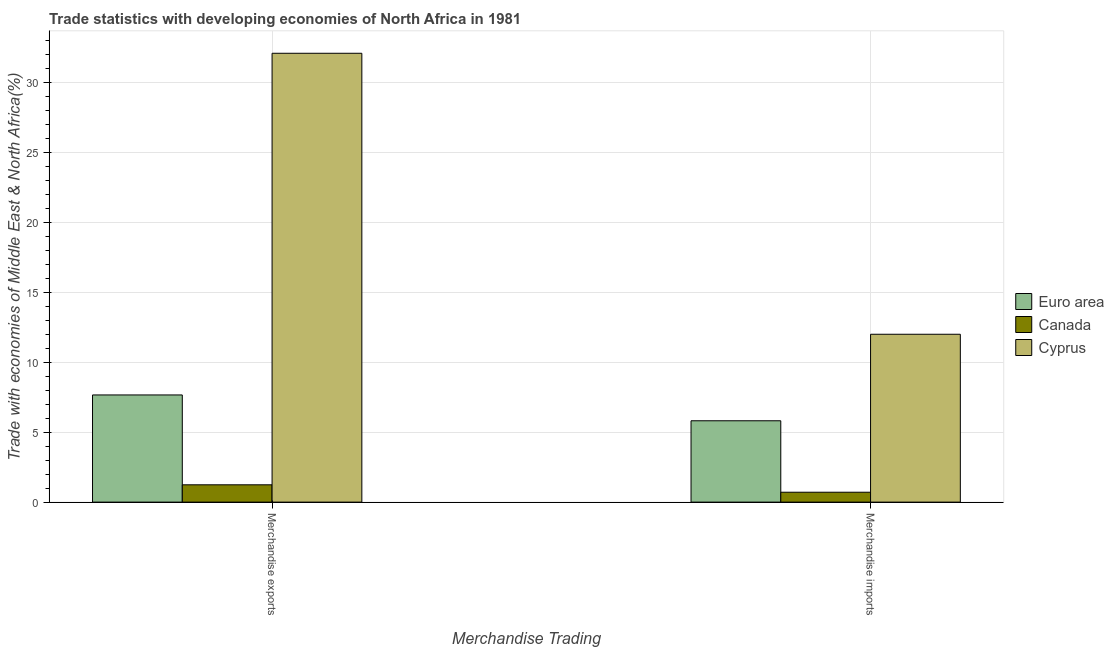How many different coloured bars are there?
Ensure brevity in your answer.  3. Are the number of bars per tick equal to the number of legend labels?
Make the answer very short. Yes. Are the number of bars on each tick of the X-axis equal?
Your answer should be compact. Yes. What is the label of the 1st group of bars from the left?
Provide a short and direct response. Merchandise exports. What is the merchandise exports in Cyprus?
Offer a terse response. 32.08. Across all countries, what is the maximum merchandise imports?
Give a very brief answer. 12. Across all countries, what is the minimum merchandise exports?
Your response must be concise. 1.24. In which country was the merchandise exports maximum?
Give a very brief answer. Cyprus. In which country was the merchandise exports minimum?
Offer a very short reply. Canada. What is the total merchandise imports in the graph?
Your answer should be very brief. 18.52. What is the difference between the merchandise exports in Euro area and that in Canada?
Your answer should be very brief. 6.42. What is the difference between the merchandise exports in Cyprus and the merchandise imports in Canada?
Your response must be concise. 31.37. What is the average merchandise exports per country?
Make the answer very short. 13.66. What is the difference between the merchandise imports and merchandise exports in Euro area?
Ensure brevity in your answer.  -1.85. In how many countries, is the merchandise exports greater than 7 %?
Make the answer very short. 2. What is the ratio of the merchandise exports in Euro area to that in Cyprus?
Your response must be concise. 0.24. Is the merchandise exports in Euro area less than that in Cyprus?
Your answer should be compact. Yes. What does the 3rd bar from the left in Merchandise imports represents?
Offer a very short reply. Cyprus. What does the 1st bar from the right in Merchandise exports represents?
Offer a very short reply. Cyprus. What is the difference between two consecutive major ticks on the Y-axis?
Your answer should be compact. 5. Does the graph contain any zero values?
Provide a short and direct response. No. Does the graph contain grids?
Make the answer very short. Yes. What is the title of the graph?
Your answer should be very brief. Trade statistics with developing economies of North Africa in 1981. Does "Tanzania" appear as one of the legend labels in the graph?
Your answer should be compact. No. What is the label or title of the X-axis?
Give a very brief answer. Merchandise Trading. What is the label or title of the Y-axis?
Provide a succinct answer. Trade with economies of Middle East & North Africa(%). What is the Trade with economies of Middle East & North Africa(%) in Euro area in Merchandise exports?
Provide a succinct answer. 7.66. What is the Trade with economies of Middle East & North Africa(%) of Canada in Merchandise exports?
Ensure brevity in your answer.  1.24. What is the Trade with economies of Middle East & North Africa(%) in Cyprus in Merchandise exports?
Provide a short and direct response. 32.08. What is the Trade with economies of Middle East & North Africa(%) in Euro area in Merchandise imports?
Give a very brief answer. 5.81. What is the Trade with economies of Middle East & North Africa(%) in Canada in Merchandise imports?
Offer a terse response. 0.71. What is the Trade with economies of Middle East & North Africa(%) in Cyprus in Merchandise imports?
Provide a succinct answer. 12. Across all Merchandise Trading, what is the maximum Trade with economies of Middle East & North Africa(%) in Euro area?
Your response must be concise. 7.66. Across all Merchandise Trading, what is the maximum Trade with economies of Middle East & North Africa(%) of Canada?
Offer a terse response. 1.24. Across all Merchandise Trading, what is the maximum Trade with economies of Middle East & North Africa(%) of Cyprus?
Offer a very short reply. 32.08. Across all Merchandise Trading, what is the minimum Trade with economies of Middle East & North Africa(%) of Euro area?
Offer a very short reply. 5.81. Across all Merchandise Trading, what is the minimum Trade with economies of Middle East & North Africa(%) in Canada?
Ensure brevity in your answer.  0.71. Across all Merchandise Trading, what is the minimum Trade with economies of Middle East & North Africa(%) in Cyprus?
Your answer should be compact. 12. What is the total Trade with economies of Middle East & North Africa(%) of Euro area in the graph?
Provide a succinct answer. 13.47. What is the total Trade with economies of Middle East & North Africa(%) in Canada in the graph?
Offer a very short reply. 1.95. What is the total Trade with economies of Middle East & North Africa(%) of Cyprus in the graph?
Your answer should be compact. 44.08. What is the difference between the Trade with economies of Middle East & North Africa(%) of Euro area in Merchandise exports and that in Merchandise imports?
Ensure brevity in your answer.  1.85. What is the difference between the Trade with economies of Middle East & North Africa(%) of Canada in Merchandise exports and that in Merchandise imports?
Offer a terse response. 0.53. What is the difference between the Trade with economies of Middle East & North Africa(%) in Cyprus in Merchandise exports and that in Merchandise imports?
Provide a succinct answer. 20.08. What is the difference between the Trade with economies of Middle East & North Africa(%) of Euro area in Merchandise exports and the Trade with economies of Middle East & North Africa(%) of Canada in Merchandise imports?
Ensure brevity in your answer.  6.95. What is the difference between the Trade with economies of Middle East & North Africa(%) of Euro area in Merchandise exports and the Trade with economies of Middle East & North Africa(%) of Cyprus in Merchandise imports?
Offer a very short reply. -4.34. What is the difference between the Trade with economies of Middle East & North Africa(%) of Canada in Merchandise exports and the Trade with economies of Middle East & North Africa(%) of Cyprus in Merchandise imports?
Your response must be concise. -10.76. What is the average Trade with economies of Middle East & North Africa(%) of Euro area per Merchandise Trading?
Offer a very short reply. 6.74. What is the average Trade with economies of Middle East & North Africa(%) of Canada per Merchandise Trading?
Provide a succinct answer. 0.97. What is the average Trade with economies of Middle East & North Africa(%) in Cyprus per Merchandise Trading?
Offer a terse response. 22.04. What is the difference between the Trade with economies of Middle East & North Africa(%) in Euro area and Trade with economies of Middle East & North Africa(%) in Canada in Merchandise exports?
Your response must be concise. 6.42. What is the difference between the Trade with economies of Middle East & North Africa(%) of Euro area and Trade with economies of Middle East & North Africa(%) of Cyprus in Merchandise exports?
Your answer should be compact. -24.42. What is the difference between the Trade with economies of Middle East & North Africa(%) in Canada and Trade with economies of Middle East & North Africa(%) in Cyprus in Merchandise exports?
Offer a terse response. -30.84. What is the difference between the Trade with economies of Middle East & North Africa(%) of Euro area and Trade with economies of Middle East & North Africa(%) of Canada in Merchandise imports?
Your answer should be compact. 5.11. What is the difference between the Trade with economies of Middle East & North Africa(%) of Euro area and Trade with economies of Middle East & North Africa(%) of Cyprus in Merchandise imports?
Offer a very short reply. -6.18. What is the difference between the Trade with economies of Middle East & North Africa(%) in Canada and Trade with economies of Middle East & North Africa(%) in Cyprus in Merchandise imports?
Your answer should be compact. -11.29. What is the ratio of the Trade with economies of Middle East & North Africa(%) of Euro area in Merchandise exports to that in Merchandise imports?
Provide a succinct answer. 1.32. What is the ratio of the Trade with economies of Middle East & North Africa(%) in Canada in Merchandise exports to that in Merchandise imports?
Your answer should be compact. 1.75. What is the ratio of the Trade with economies of Middle East & North Africa(%) of Cyprus in Merchandise exports to that in Merchandise imports?
Provide a short and direct response. 2.67. What is the difference between the highest and the second highest Trade with economies of Middle East & North Africa(%) in Euro area?
Keep it short and to the point. 1.85. What is the difference between the highest and the second highest Trade with economies of Middle East & North Africa(%) in Canada?
Offer a terse response. 0.53. What is the difference between the highest and the second highest Trade with economies of Middle East & North Africa(%) in Cyprus?
Your answer should be very brief. 20.08. What is the difference between the highest and the lowest Trade with economies of Middle East & North Africa(%) in Euro area?
Ensure brevity in your answer.  1.85. What is the difference between the highest and the lowest Trade with economies of Middle East & North Africa(%) in Canada?
Give a very brief answer. 0.53. What is the difference between the highest and the lowest Trade with economies of Middle East & North Africa(%) of Cyprus?
Ensure brevity in your answer.  20.08. 